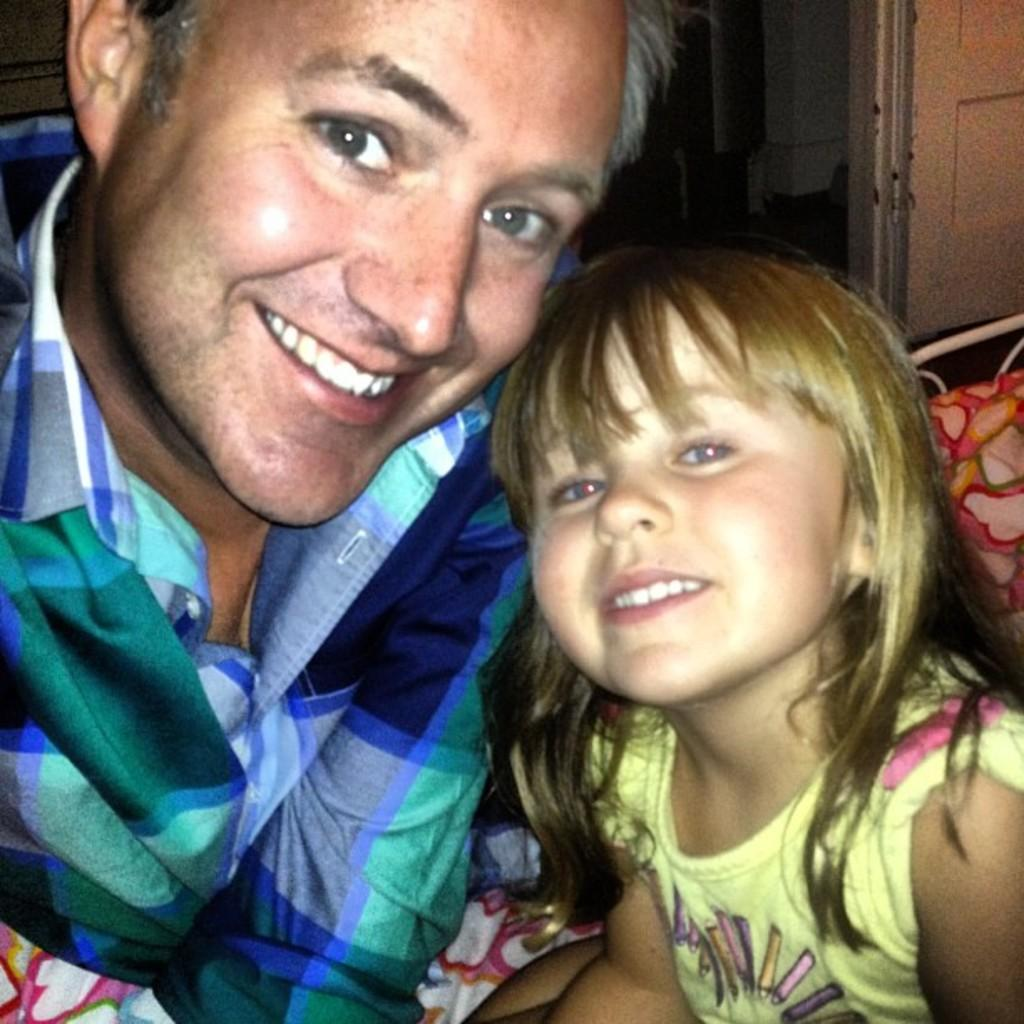Who are the people in the image? There is a man and a girl in the image. What are the expressions on their faces? Both the man and the girl are smiling. What can be seen in the background of the image? There is a wall and a bed in the background of the image. How many snakes are slithering on the bed in the image? There are no snakes present in the image; it only features a man, a girl, and the background elements. What nation is represented by the flag in the image? There is no flag present in the image, so it is not possible to determine which nation might be represented. 